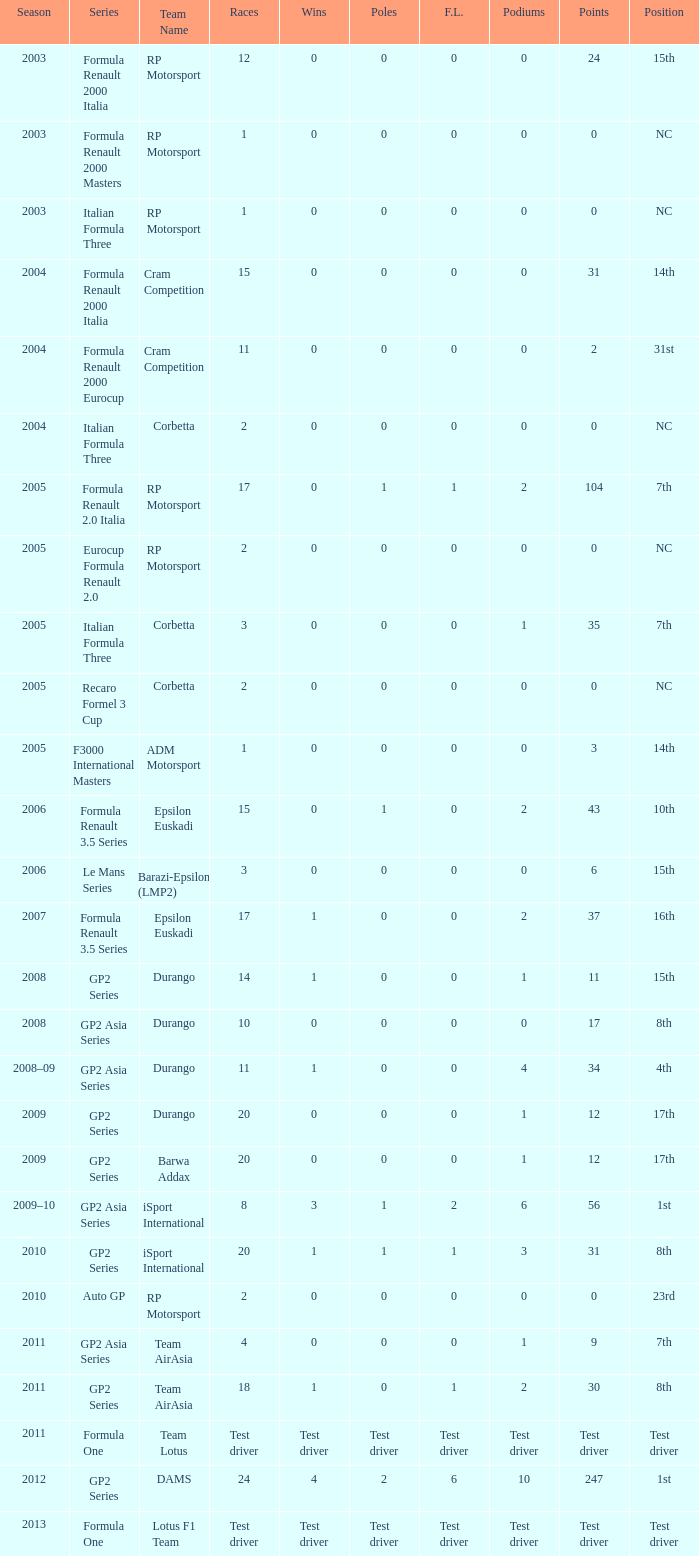What races have gp2 series, 0 F.L. and a 17th position? 20, 20. 